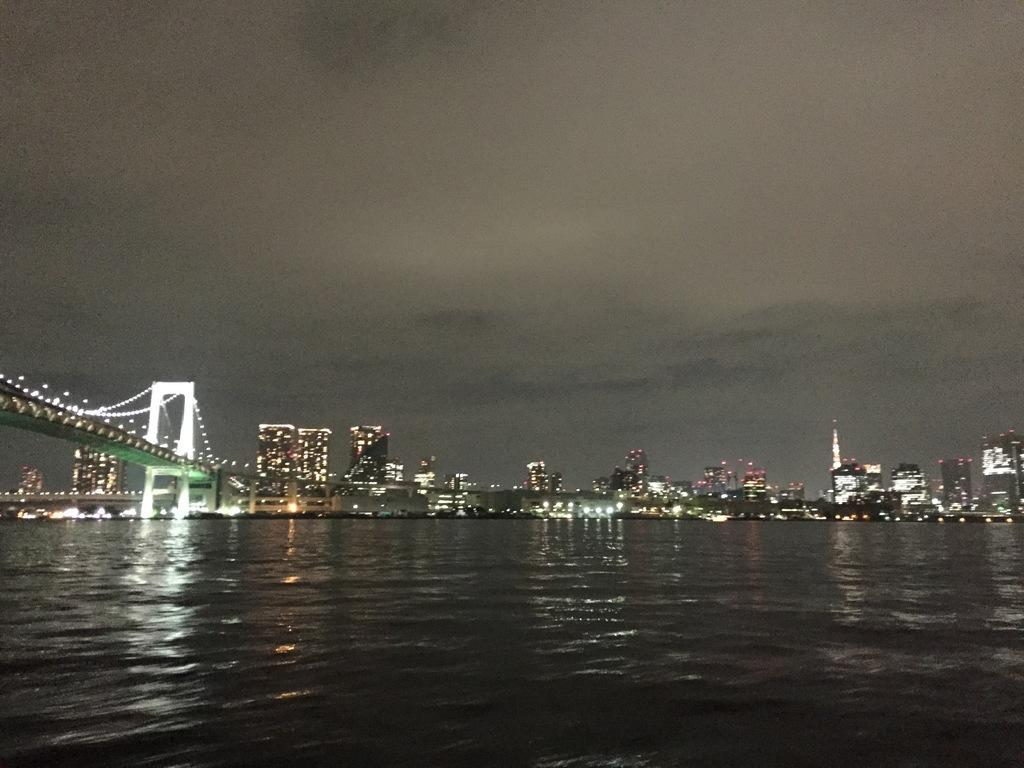What structure is present in the image? There is a bridge in the image. Where is the bridge located in relation to the water? The bridge is located over water in the image. On which side of the image is the bridge situated? The bridge is on the left side of the image. What can be seen in the background of the image? There are lights and buildings visible in the background of the image. What role does the sister play in the construction of the bridge in the image? There is no mention of a sister in the image or the facts provided, so we cannot determine any role she might play. 